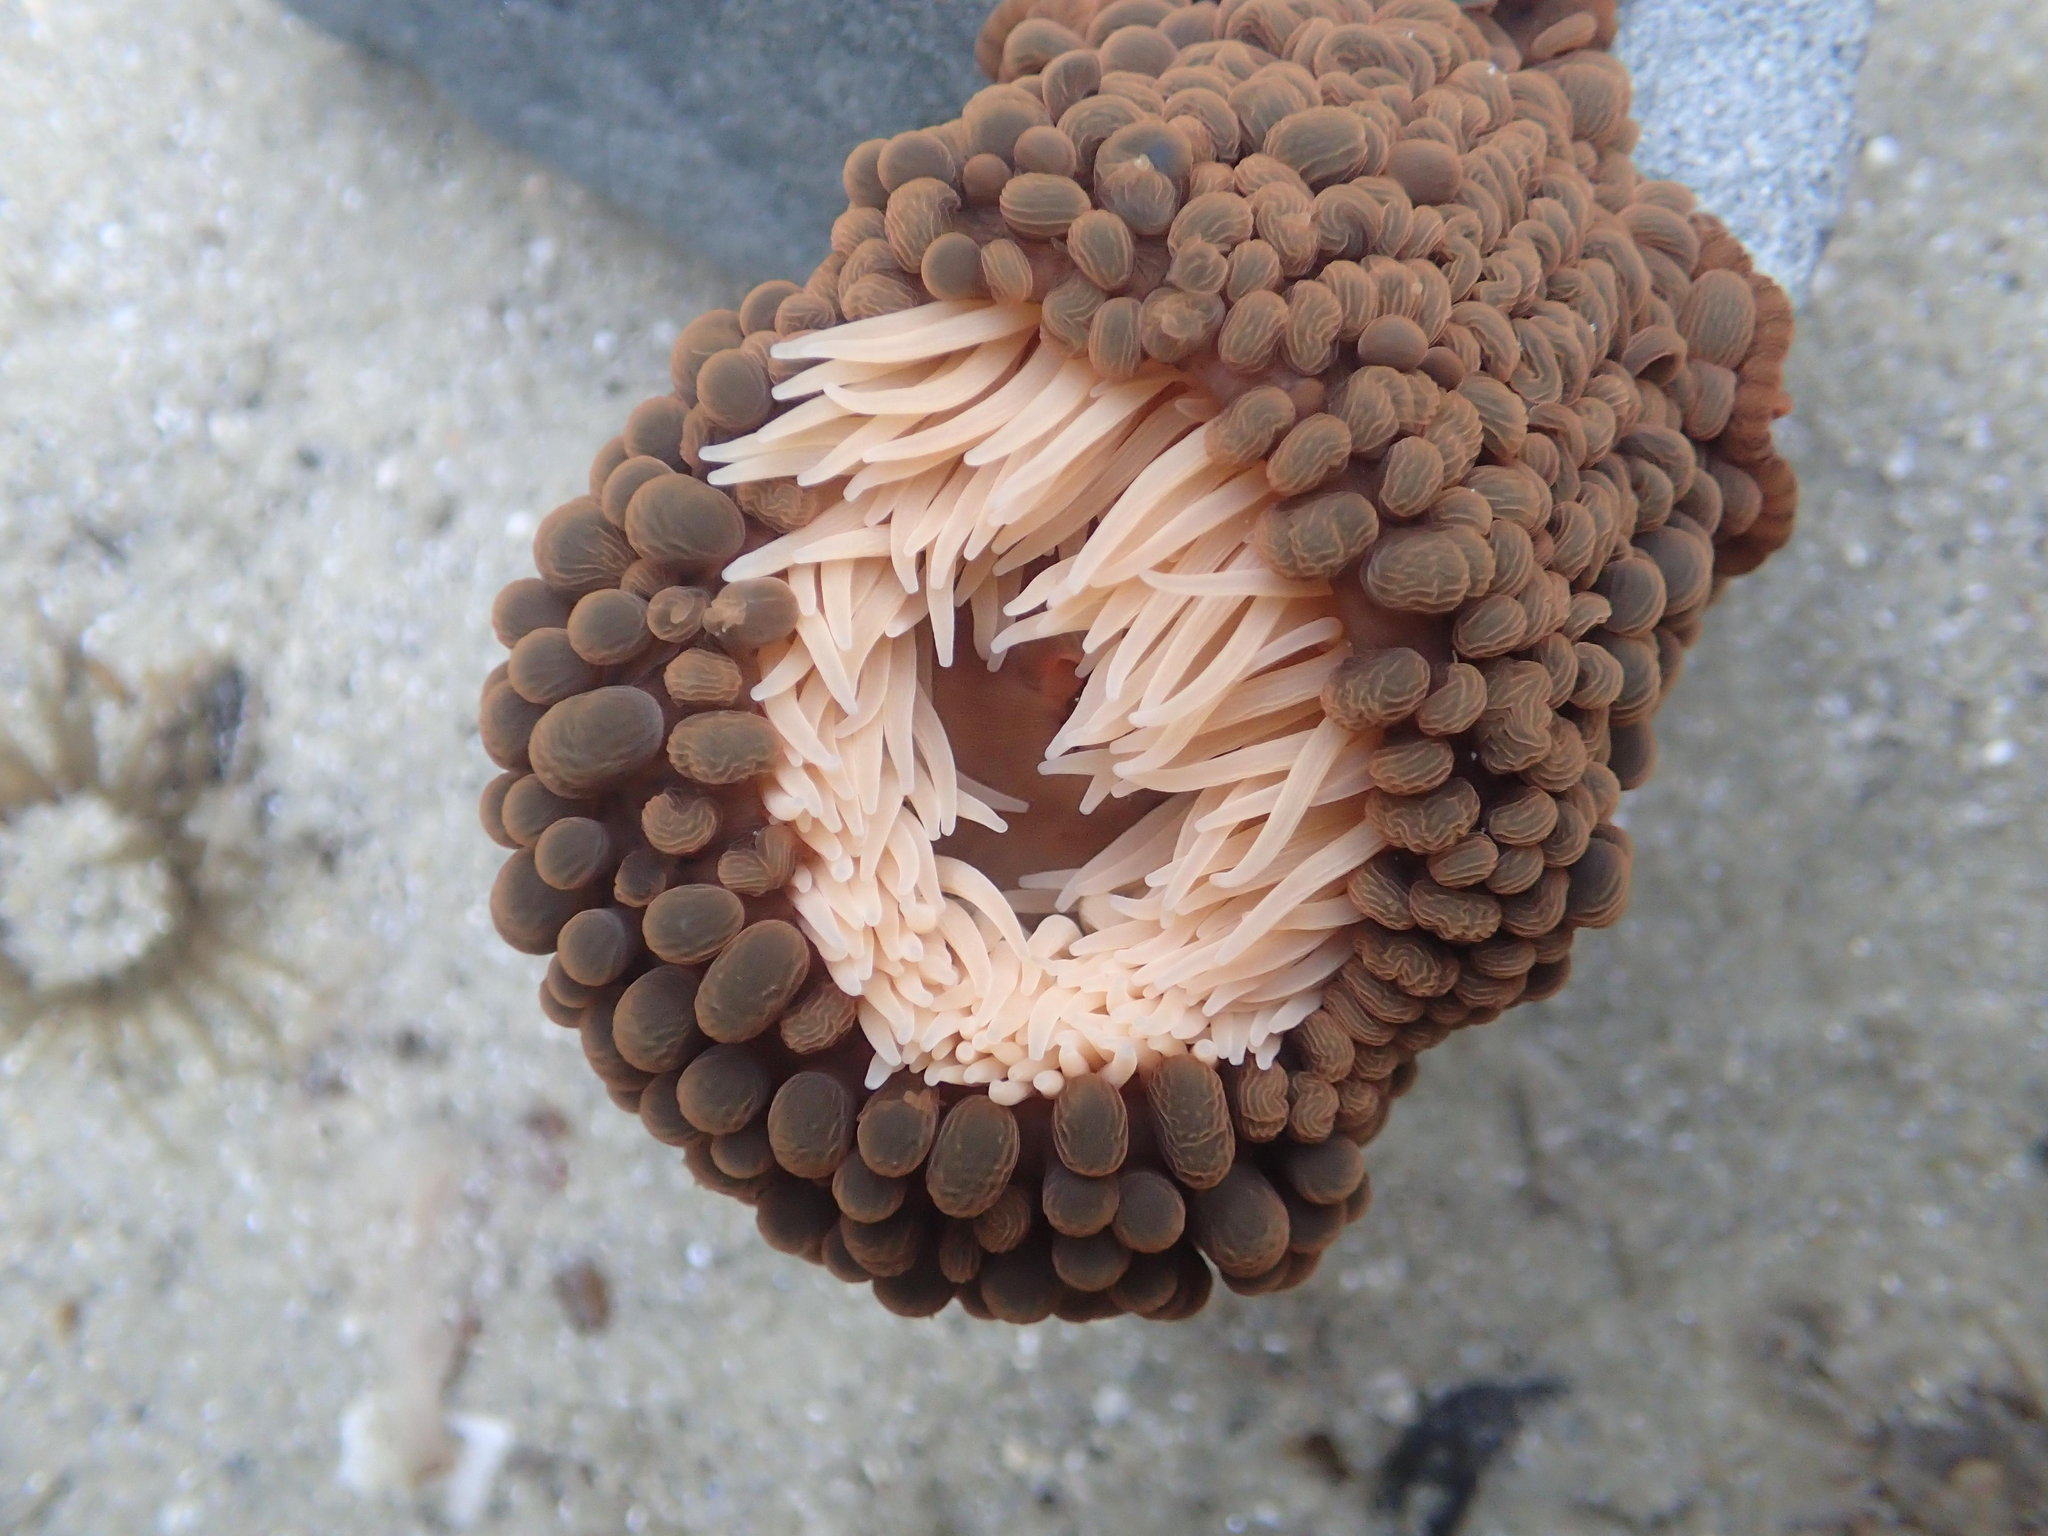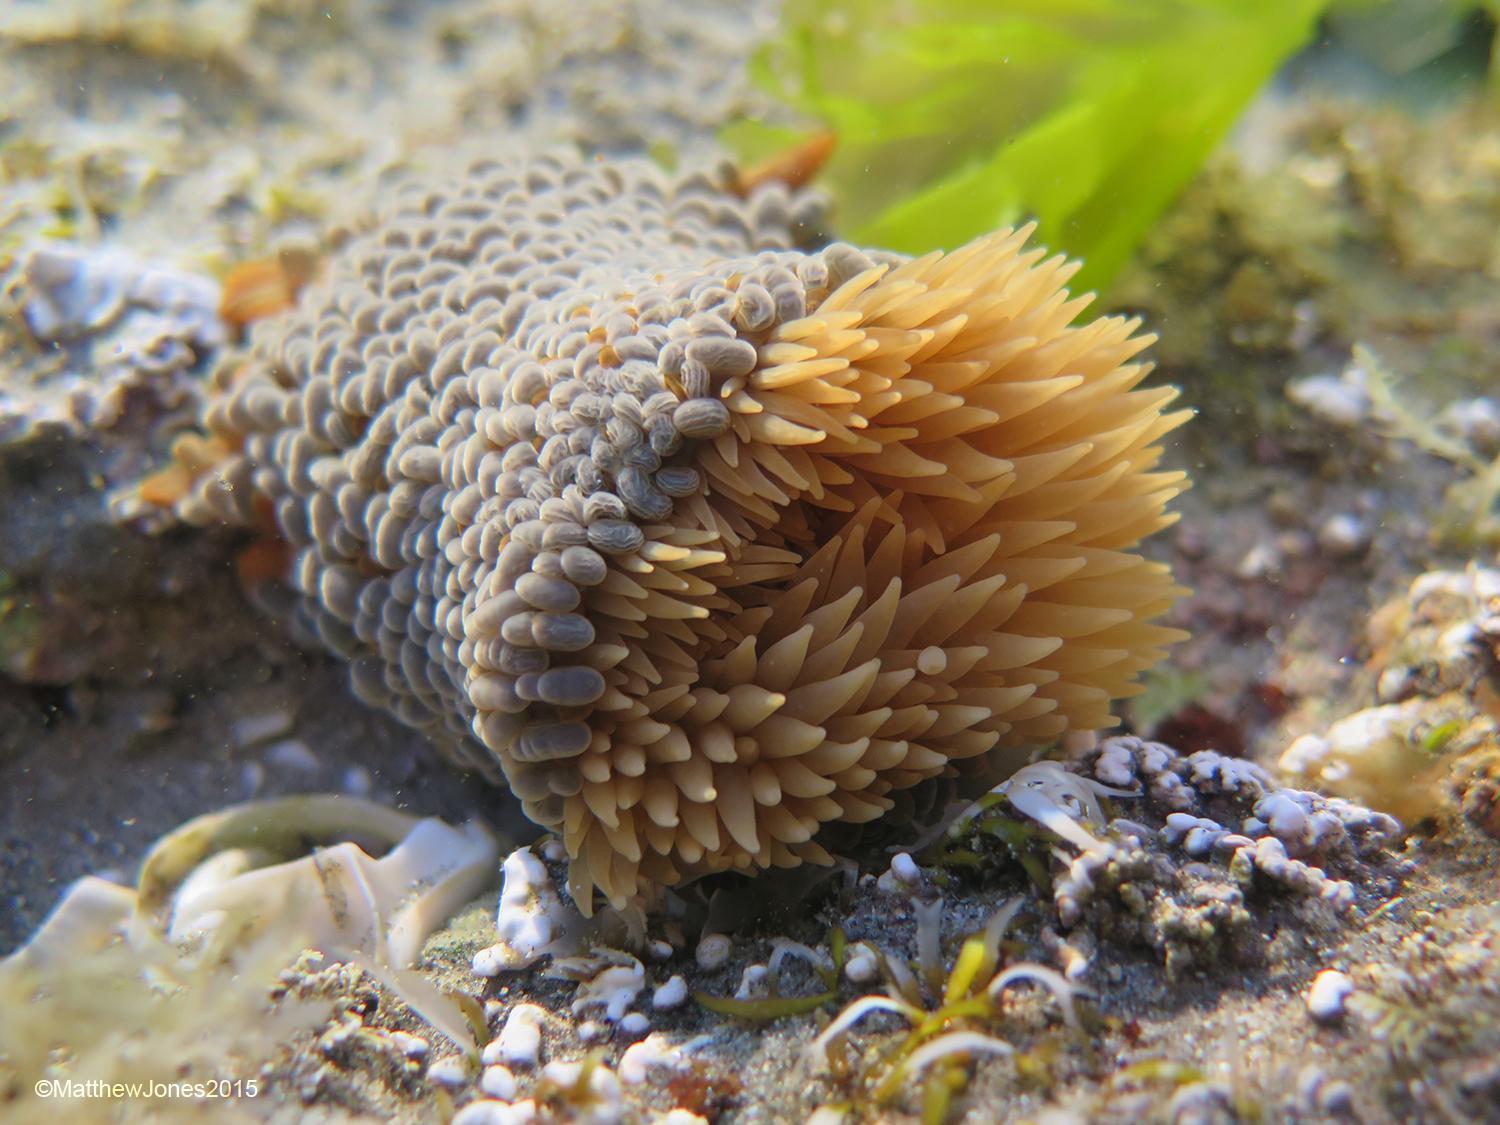The first image is the image on the left, the second image is the image on the right. Evaluate the accuracy of this statement regarding the images: "The right image shows anemone tendrils emerging from a stalk covered with oval shapes.". Is it true? Answer yes or no. Yes. 